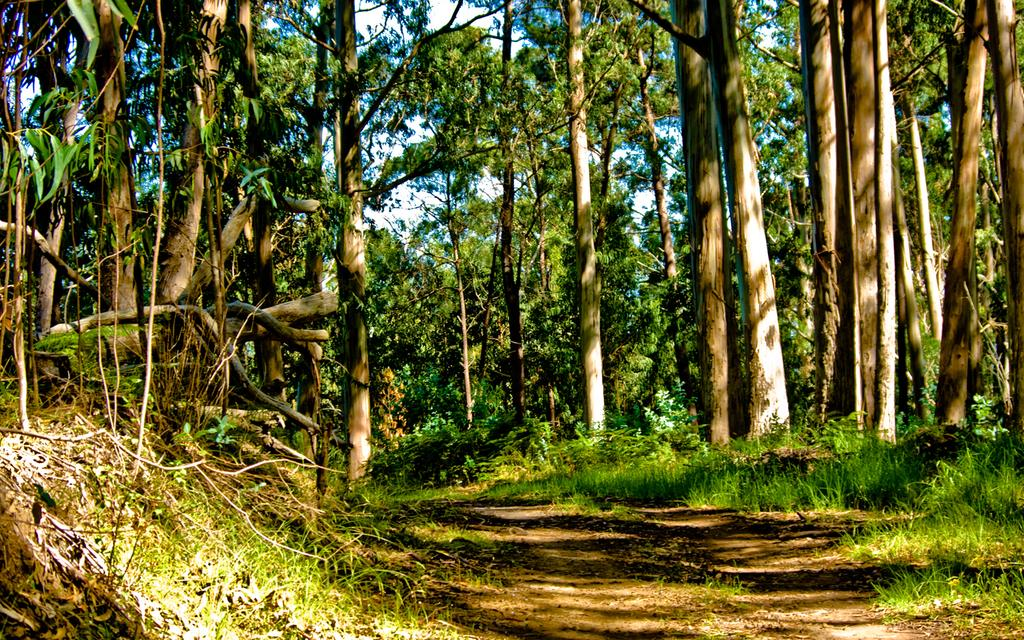What type of vegetation is present in the image? There are trees in the image. What type of ground cover is visible at the bottom of the image? There is grass at the bottom of the image. What part of the natural environment is visible in the background of the image? The sky is visible in the background of the image. Where is the beginner's guide to using a vase located in the image? There is no beginner's guide or vase present in the image. What type of copy is being made of the trees in the image? There is no copying or duplication of the trees in the image; they are naturally occurring. 